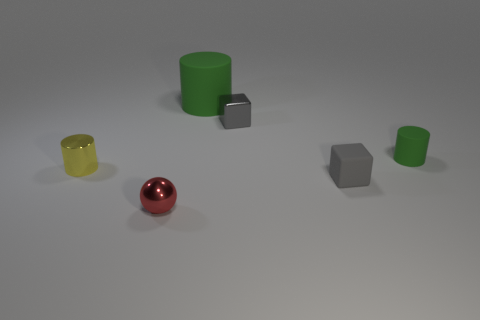Subtract all rubber cylinders. How many cylinders are left? 1 Subtract all gray blocks. How many green cylinders are left? 2 Add 1 small green cubes. How many objects exist? 7 Subtract all green cylinders. How many cylinders are left? 1 Subtract 1 cylinders. How many cylinders are left? 2 Subtract all gray cylinders. Subtract all yellow cubes. How many cylinders are left? 3 Add 5 big cylinders. How many big cylinders are left? 6 Add 2 gray metal objects. How many gray metal objects exist? 3 Subtract 1 yellow cylinders. How many objects are left? 5 Subtract all spheres. How many objects are left? 5 